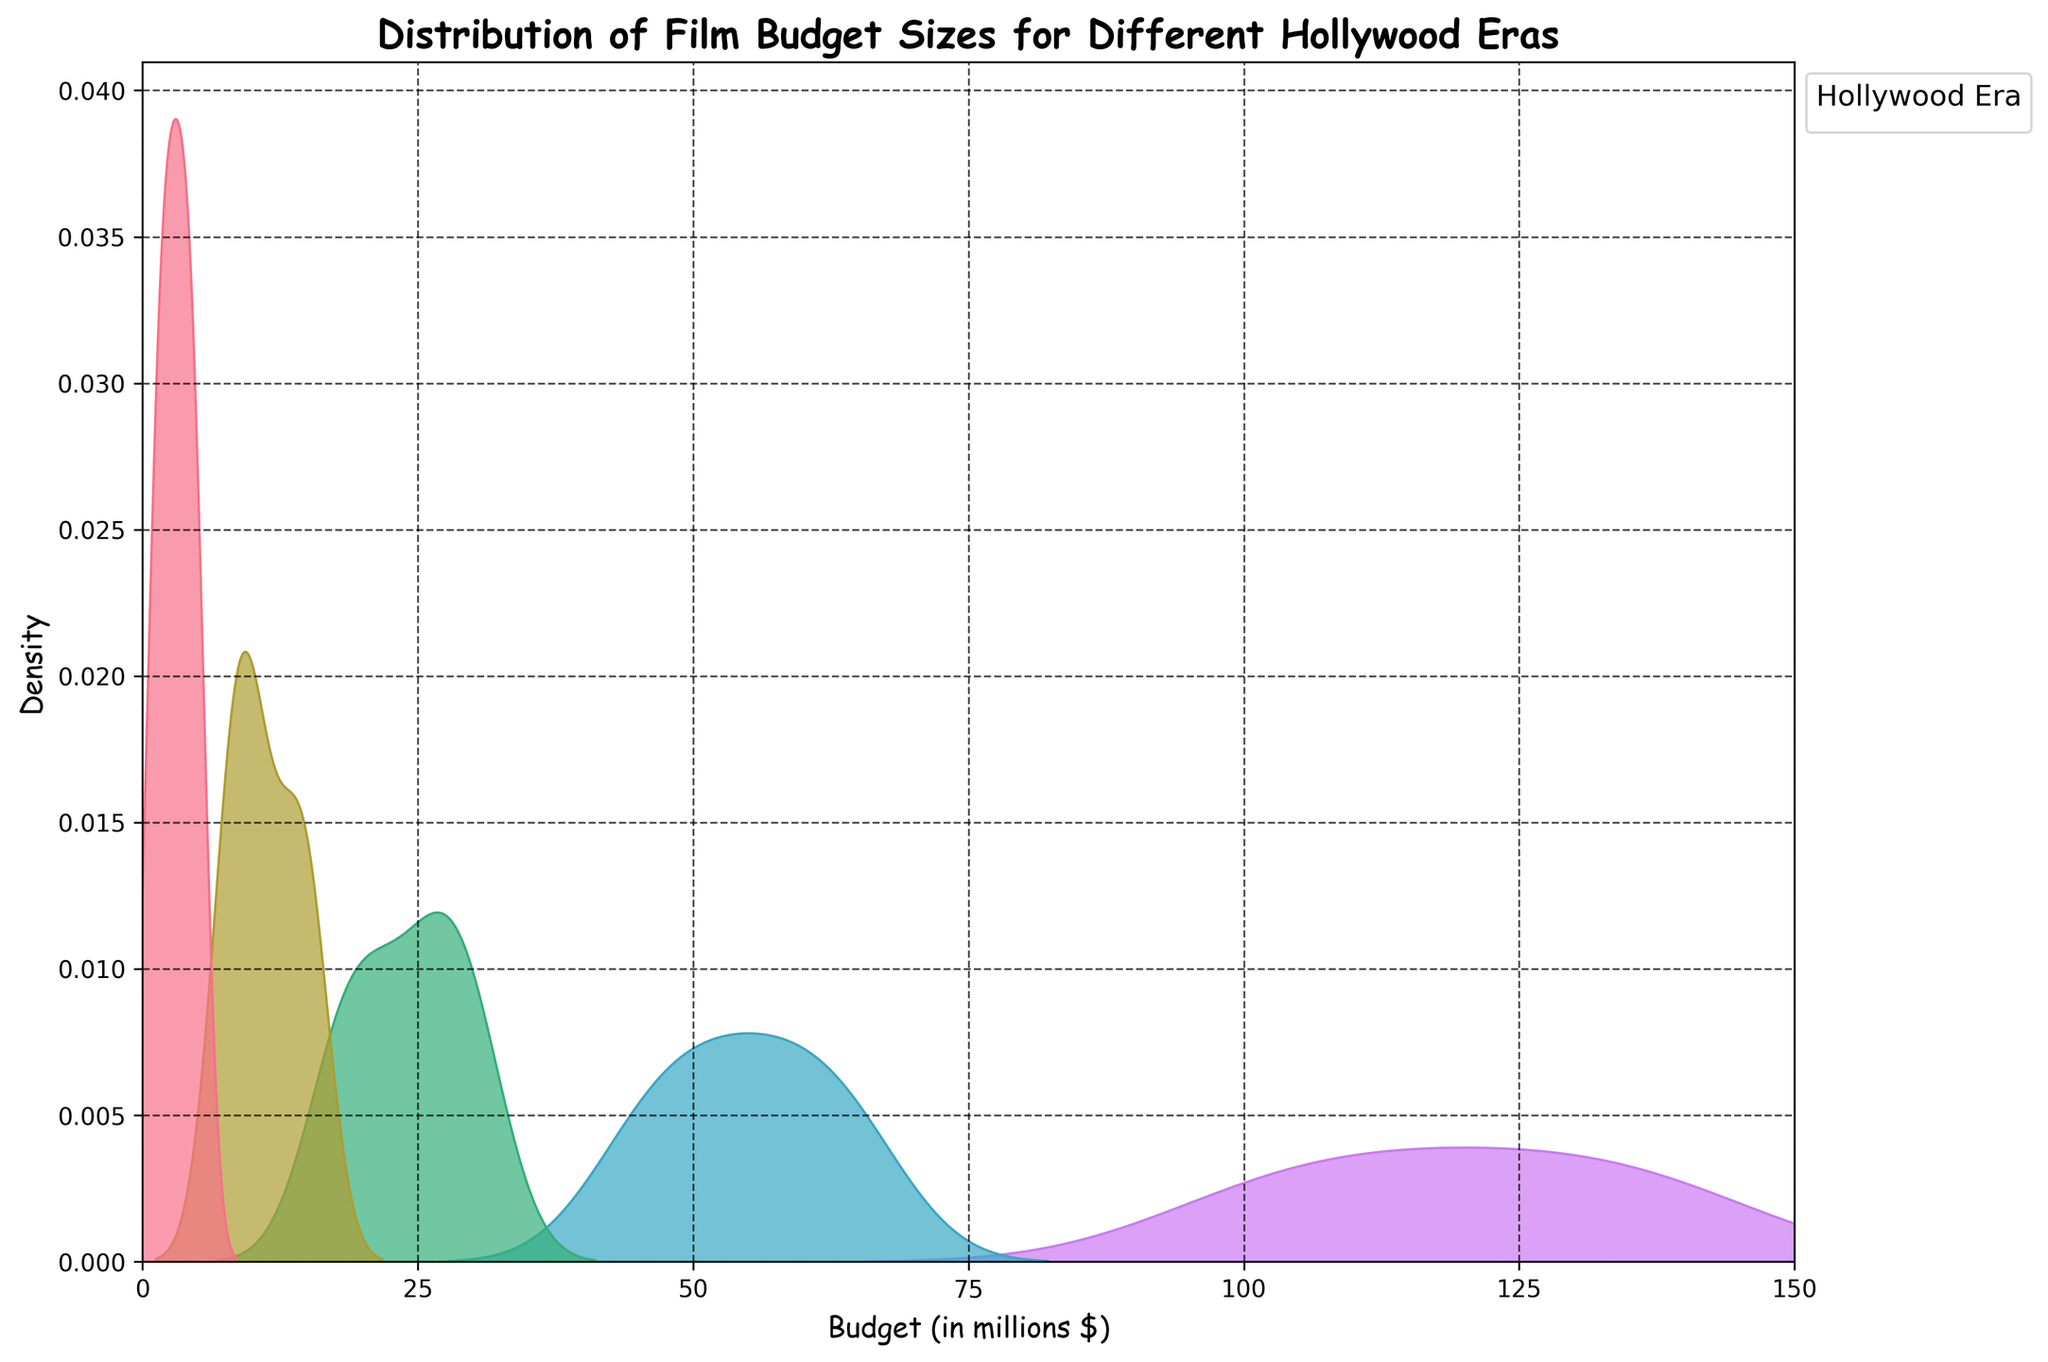What's the title of the figure? The title is usually the most prominent text at the top of the figure. In this case, it's clearly displayed as "Distribution of Film Budget Sizes for Different Hollywood Eras".
Answer: "Distribution of Film Budget Sizes for Different Hollywood Eras" What is the budget range covered on the x-axis? The x-axis label represents the budget and it spans from 0 to 150 million dollars.
Answer: 0 to 150 million dollars Which era shows the highest peak density? The highest peak density in a density plot appears as the tallest curve. Here, it seems the Modern Hollywood (2000-present) era has the highest peak density.
Answer: Modern Hollywood (2000-present) Is there a clear separation between the budget distributions of the different eras? The density curves indicate whether there is overlap or clear separation. The curves show distinct peaks at different budget ranges, indicating clear separation between eras.
Answer: Yes Which era has the lowest budget density distribution? The lowest peak on the density plot represents the era with the lowest density distribution. The Golden Age of Hollywood (1930-1945) seems to have the lowest peaks.
Answer: Golden Age of Hollywood (1930-1945) How do the budget distributions of the Golden Age of Hollywood and Blockbuster Era compare? By observing the plot, the Golden Age of Hollywood budgets are clustered around the lower end (1-5 million dollars), whereas the Blockbuster Era budgets are much higher, largely ranging from 45 to 65 million dollars.
Answer: Golden Age: 1-5 million dollars, Blockbuster Era: 45-65 million dollars Which era shows the greatest range in budget sizes? The range in budget sizes is indicated by the spread of the density curve on the x-axis. The Modern Hollywood (2000-present) era shows the widest spread, from 100 to 140 million dollars.
Answer: Modern Hollywood (2000-present) What is the midpoint (median) of the budget distribution for New Hollywood (1966-1980)? By examining the curve's shape, the midpoint where the curve peaks for New Hollywood appears around 25 million dollars.
Answer: Approximately 25 million dollars Which era has a budget density peak closest to 50 million dollars? Observing the budget axis and the density plots, the Blockbuster Era (1981-1999) has a peak density close to 50 million dollars.
Answer: Blockbuster Era (1981-1999) Are there any eras where the budget distributions overlap significantly? Overlapping would be indicated by curves that share similar regions on the x-axis. The Post-War Hollywood (1946-1965) and New Hollywood (1966-1980) eras have some overlap in the range of 8 to 15 million dollars.
Answer: Yes, Post-War Hollywood and New Hollywood 